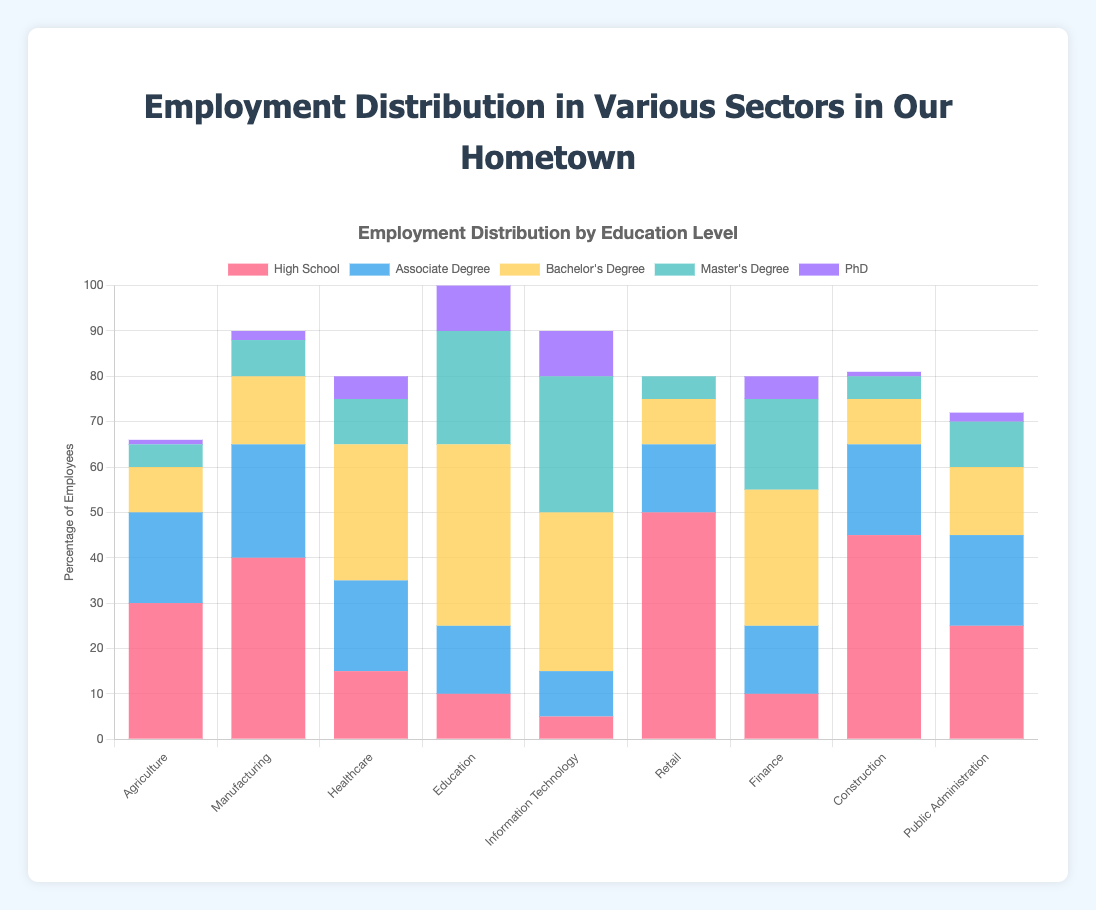What is the most common educational background in the Agriculture sector? Look at the segment of the Agriculture sector corresponding to each educational background. The tallest bar segment represents "High School."
Answer: High School Which sector has the highest number of employees with a Bachelor's Degree? Compare the segments for Bachelor's Degree across all sectors. The "Education" sector has the highest bar segment.
Answer: Education Are there more employees with a Master's Degree in IT or in Healthcare? Compare the bar segments for Master's Degree in the Information Technology and Healthcare sectors. IT has 30, Healthcare has 10.
Answer: Information Technology What is the total number of employees in the Manufacturing sector? Sum the number of employees in the Manufacturing sector across all educational backgrounds: 40 (High School) + 25 (Associate Degree) + 15 (Bachelor's Degree) + 8 (Master's Degree) + 2 (PhD) = 90.
Answer: 90 In which sector is the proportion of High School graduates the highest relative to the total number of employees in that sector? Calculate the ratios of High School graduates to the total number of employees in each sector. The "Retail" sector has the highest proportion as 50 out of the total sum of its employees.
Answer: Retail Which sector has a greater difference in the number of employees with a PhD compared to those with a High School diploma? Compute the differences between High School and PhD counts for each sector. For most sectors, the difference is significant but compare each: The most notable is IT, where the difference is 5 - 10 = -5.
Answer: Information Technology Which sectors have no employees with a PhD? Identify sectors with a 0 in the PhD category. Only "Retail" has no PhDs.
Answer: Retail What is the total number of employees with an Associate Degree across all sectors? Sum the number of employees with Associate Degrees in all sectors: 20 + 25 + 20 + 15 + 10 + 15 + 15 + 20 + 20 = 160.
Answer: 160 Which sector shows the least difference between Bachelor's Degree holders and Master's Degree holders? For each sector, calculate the absolute difference between Bachelor's Degree and Master’s Degree. The "Healthcare" sector has the smallest difference: 30 - 10 = 20.
Answer: Healthcare How many sectors have more employees with a Bachelor's Degree than with an Associate Degree? Count sectors where the Bachelor's Degree segment is taller than the Associate Degree. These sectors are: Healthcare, Education, Information Technology, and Finance (4 sectors).
Answer: 4 